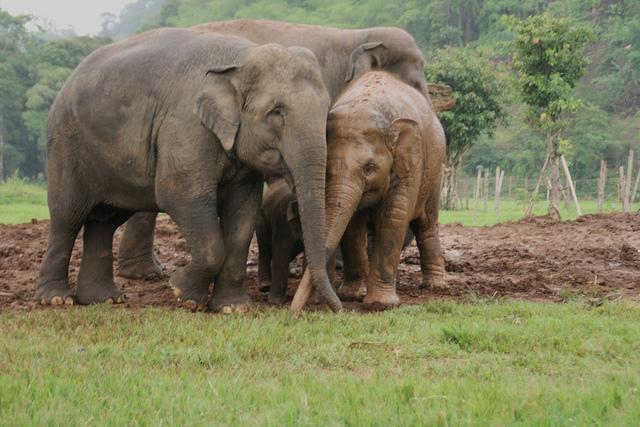How many babies are in the picture?
Give a very brief answer. 1. How many animals are there?
Give a very brief answer. 3. How many elephants are there?
Give a very brief answer. 3. How many people are to the right of the elephant?
Give a very brief answer. 0. 